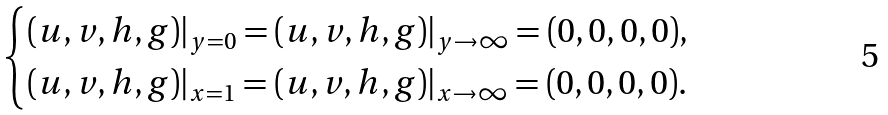Convert formula to latex. <formula><loc_0><loc_0><loc_500><loc_500>\begin{cases} ( u , v , h , g ) | _ { y = 0 } = ( u , v , h , g ) | _ { y \rightarrow \infty } = ( 0 , 0 , 0 , 0 ) , \\ ( u , v , h , g ) | _ { x = 1 } = ( u , v , h , g ) | _ { x \rightarrow \infty } = ( 0 , 0 , 0 , 0 ) . \end{cases}</formula> 